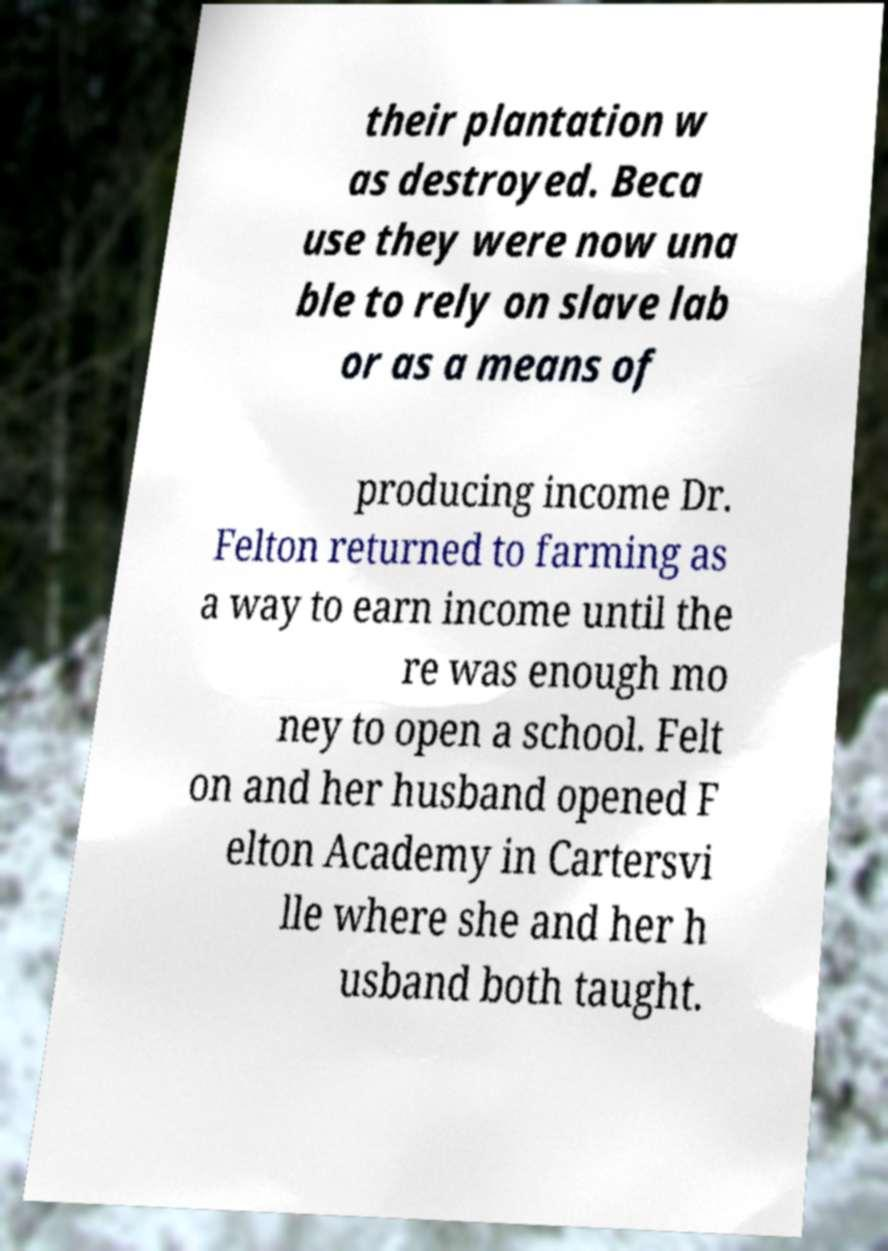I need the written content from this picture converted into text. Can you do that? their plantation w as destroyed. Beca use they were now una ble to rely on slave lab or as a means of producing income Dr. Felton returned to farming as a way to earn income until the re was enough mo ney to open a school. Felt on and her husband opened F elton Academy in Cartersvi lle where she and her h usband both taught. 